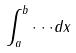<formula> <loc_0><loc_0><loc_500><loc_500>\int _ { a } ^ { b } \cdot \cdot \cdot d x</formula> 